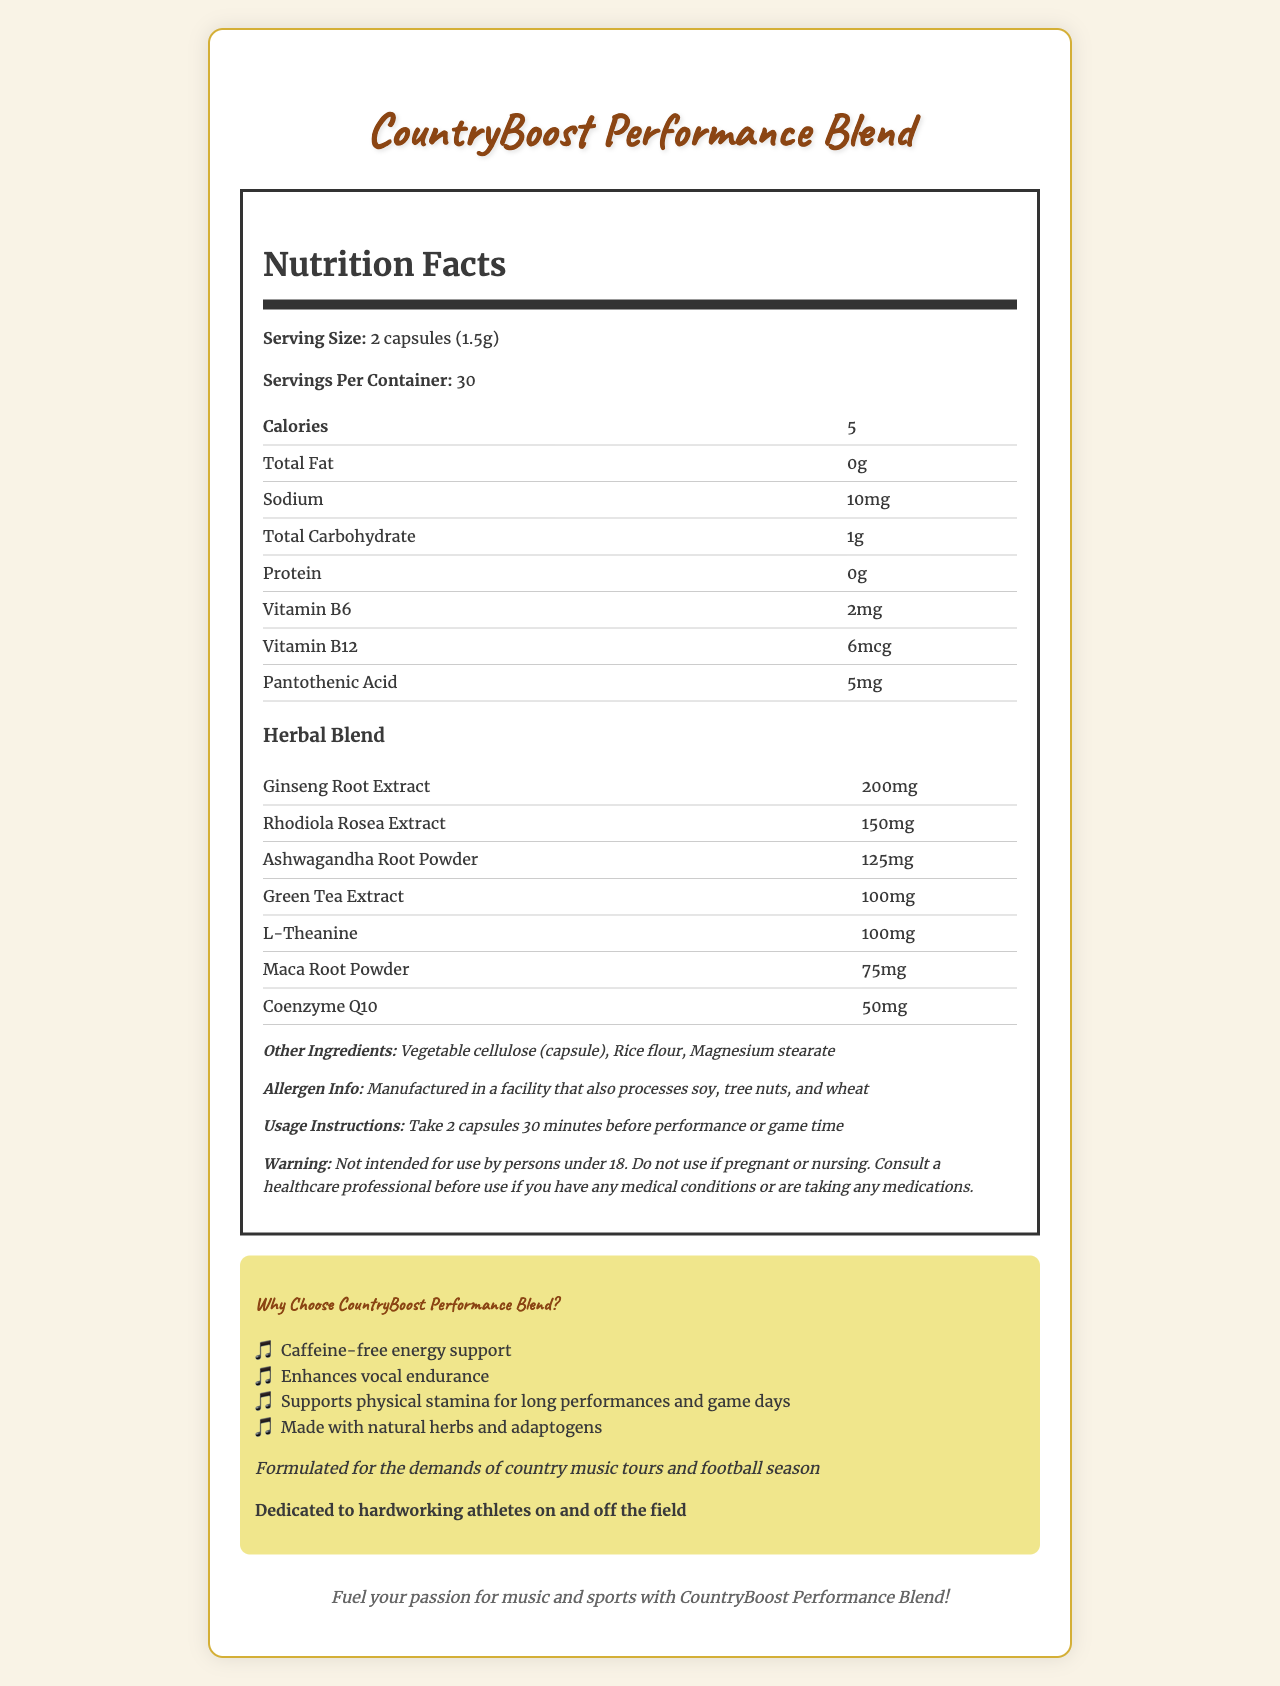what is the serving size of CountryBoost Performance Blend? The serving size information is explicitly mentioned in the Nutrition Facts section.
Answer: 2 capsules (1.5g) how many calories are there per serving of CountryBoost Performance Blend? The document lists the calorie count under the Nutrition Facts section.
Answer: 5 what is the amount of sodium per serving? The sodium content is listed directly under the Nutrition Facts section.
Answer: 10mg which herbal ingredient has the highest content per serving? The Ginseng Root Extract has the highest amount listed, which is 200mg.
Answer: Ginseng Root Extract what is the recommended usage instruction? The usage instructions are detailed at the bottom of the Nutrition Facts section.
Answer: Take 2 capsules 30 minutes before performance or game time what is the main benefit claimed for CountryBoost Performance Blend? A. Weight loss B. Caffeine-free energy support C. Immunity boost The main benefit mentioned under marketing claims is "Caffeine-free energy support".
Answer: B which vitamin is present in the highest quantity per serving in the supplement? A. Vitamin B6 B. Vitamin B12 C. Pantothenic Acid Vitamin B6 is present at 2mg, while Vitamin B12 is 6mcg and Pantothenic Acid is 5mg. Given standard units, Vitamin B6 is more substantial.
Answer: A (Vitamin B6) can this supplement be used by pregnant women? The warning section explicitly states that it should not be used if pregnant or nursing.
Answer: No does the product contain any caffeine? One of the marketing claims is "Caffeine-free energy support".
Answer: No how many servings are there in one container? The servings per container information is listed in the Nutrition Facts section.
Answer: 30 summarize the main features of CountryBoost Performance Blend. This summary captures the key details from the document including ingredients, benefits, and usage instructions.
Answer: CountryBoost Performance Blend is a caffeine-free, herbal energy supplement designed to boost stamina during long performances and game days. It contains various natural herbs and vitamins such as Ginseng Root Extract, Rhodiola Rosea Extract, and vitamins B6 and B12. It offers benefits like enhanced vocal endurance and physical stamina, tailored for country music tours and football. The recommended dosage is 2 capsules 30 minutes before performance or game time. can you provide the manufacturing country of the supplement? The document does not specify the manufacturing country of the supplement.
Answer: Not enough information 